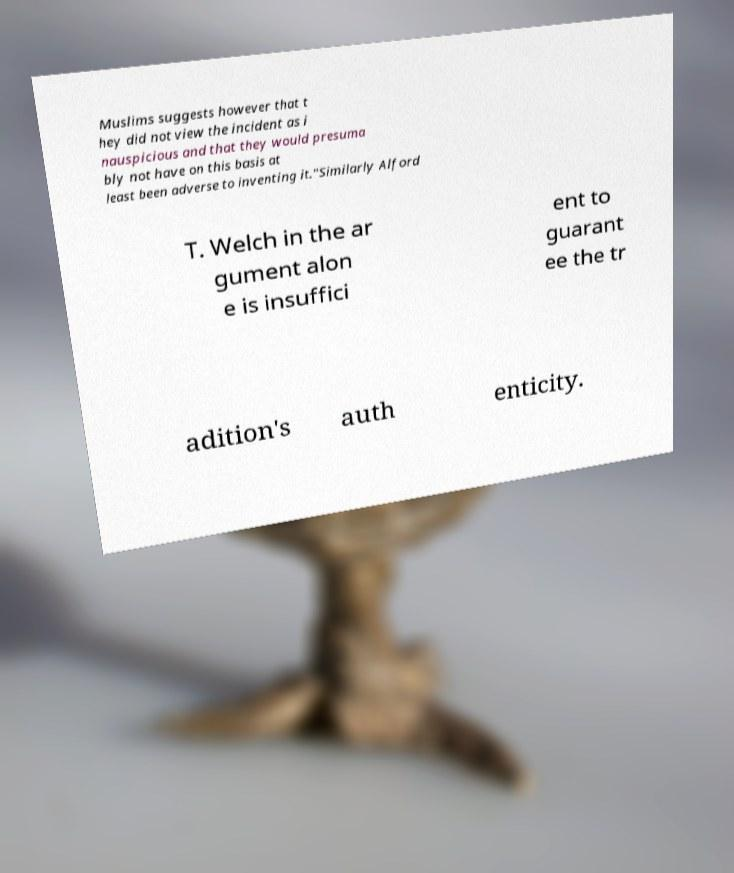What messages or text are displayed in this image? I need them in a readable, typed format. Muslims suggests however that t hey did not view the incident as i nauspicious and that they would presuma bly not have on this basis at least been adverse to inventing it."Similarly Alford T. Welch in the ar gument alon e is insuffici ent to guarant ee the tr adition's auth enticity. 